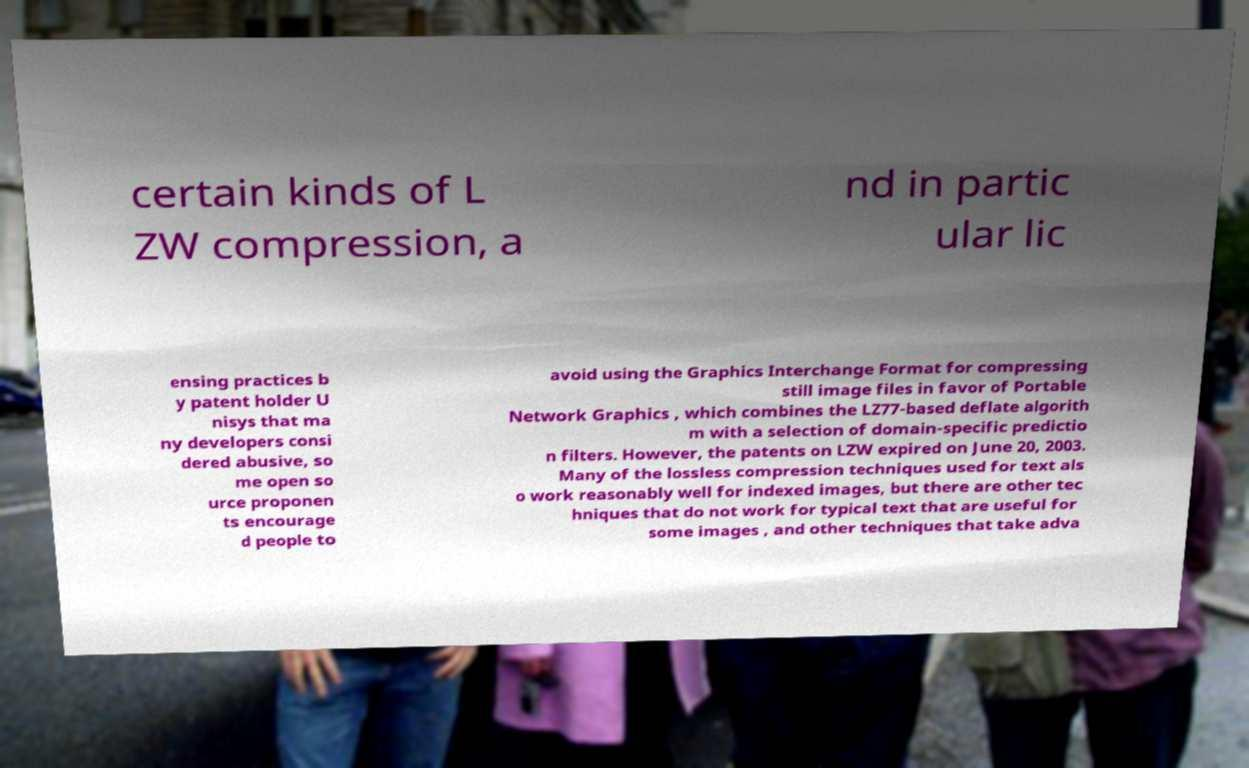What messages or text are displayed in this image? I need them in a readable, typed format. certain kinds of L ZW compression, a nd in partic ular lic ensing practices b y patent holder U nisys that ma ny developers consi dered abusive, so me open so urce proponen ts encourage d people to avoid using the Graphics Interchange Format for compressing still image files in favor of Portable Network Graphics , which combines the LZ77-based deflate algorith m with a selection of domain-specific predictio n filters. However, the patents on LZW expired on June 20, 2003. Many of the lossless compression techniques used for text als o work reasonably well for indexed images, but there are other tec hniques that do not work for typical text that are useful for some images , and other techniques that take adva 